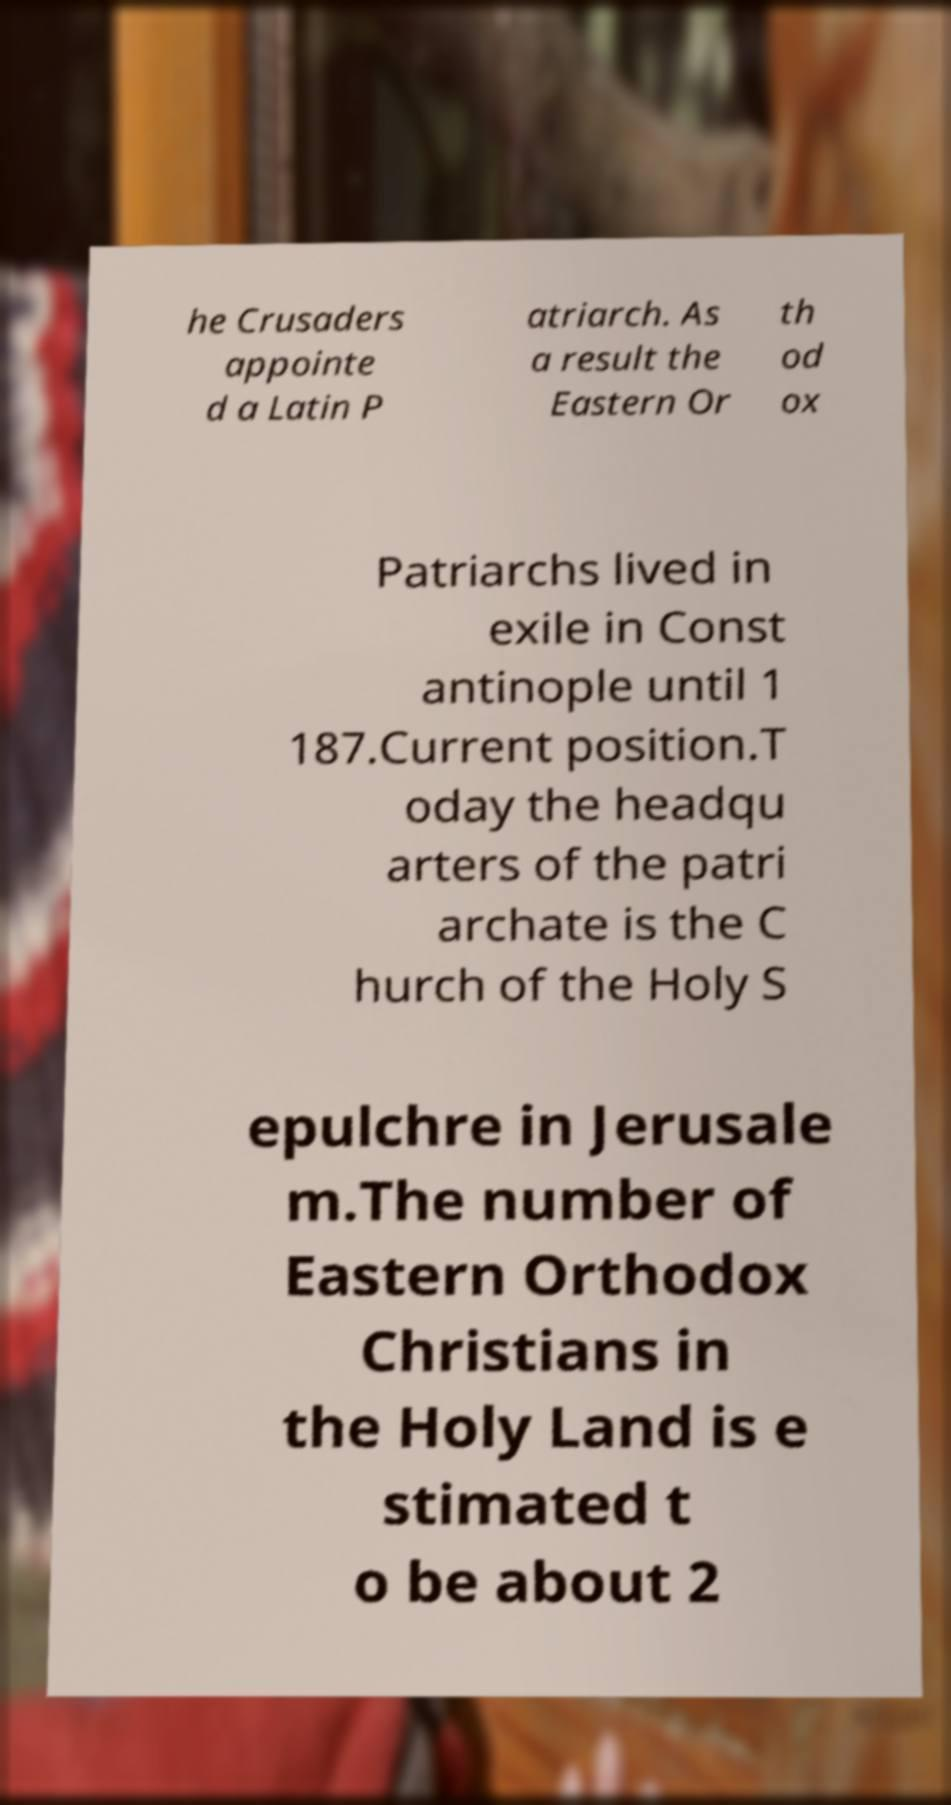For documentation purposes, I need the text within this image transcribed. Could you provide that? he Crusaders appointe d a Latin P atriarch. As a result the Eastern Or th od ox Patriarchs lived in exile in Const antinople until 1 187.Current position.T oday the headqu arters of the patri archate is the C hurch of the Holy S epulchre in Jerusale m.The number of Eastern Orthodox Christians in the Holy Land is e stimated t o be about 2 